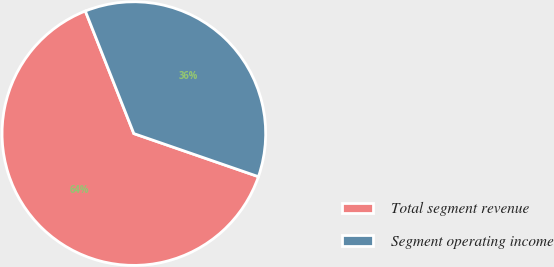<chart> <loc_0><loc_0><loc_500><loc_500><pie_chart><fcel>Total segment revenue<fcel>Segment operating income<nl><fcel>63.7%<fcel>36.3%<nl></chart> 